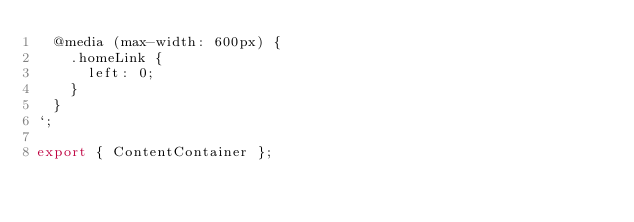Convert code to text. <code><loc_0><loc_0><loc_500><loc_500><_JavaScript_>  @media (max-width: 600px) {
    .homeLink {
      left: 0;
    }
  }
`;

export { ContentContainer };
</code> 